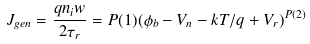<formula> <loc_0><loc_0><loc_500><loc_500>J _ { g e n } = \frac { q n _ { i } w } { 2 \tau _ { r } } = P ( 1 ) ( \phi _ { b } - V _ { n } - k T / q + V _ { r } ) ^ { P ( 2 ) }</formula> 